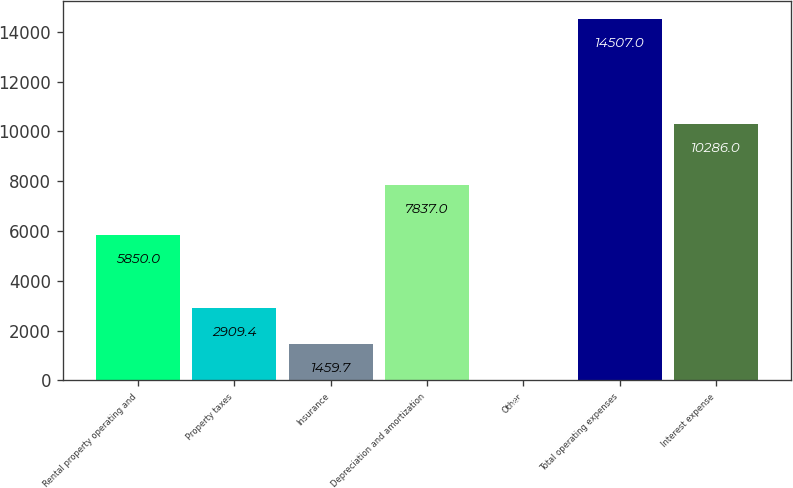Convert chart. <chart><loc_0><loc_0><loc_500><loc_500><bar_chart><fcel>Rental property operating and<fcel>Property taxes<fcel>Insurance<fcel>Depreciation and amortization<fcel>Other<fcel>Total operating expenses<fcel>Interest expense<nl><fcel>5850<fcel>2909.4<fcel>1459.7<fcel>7837<fcel>10<fcel>14507<fcel>10286<nl></chart> 